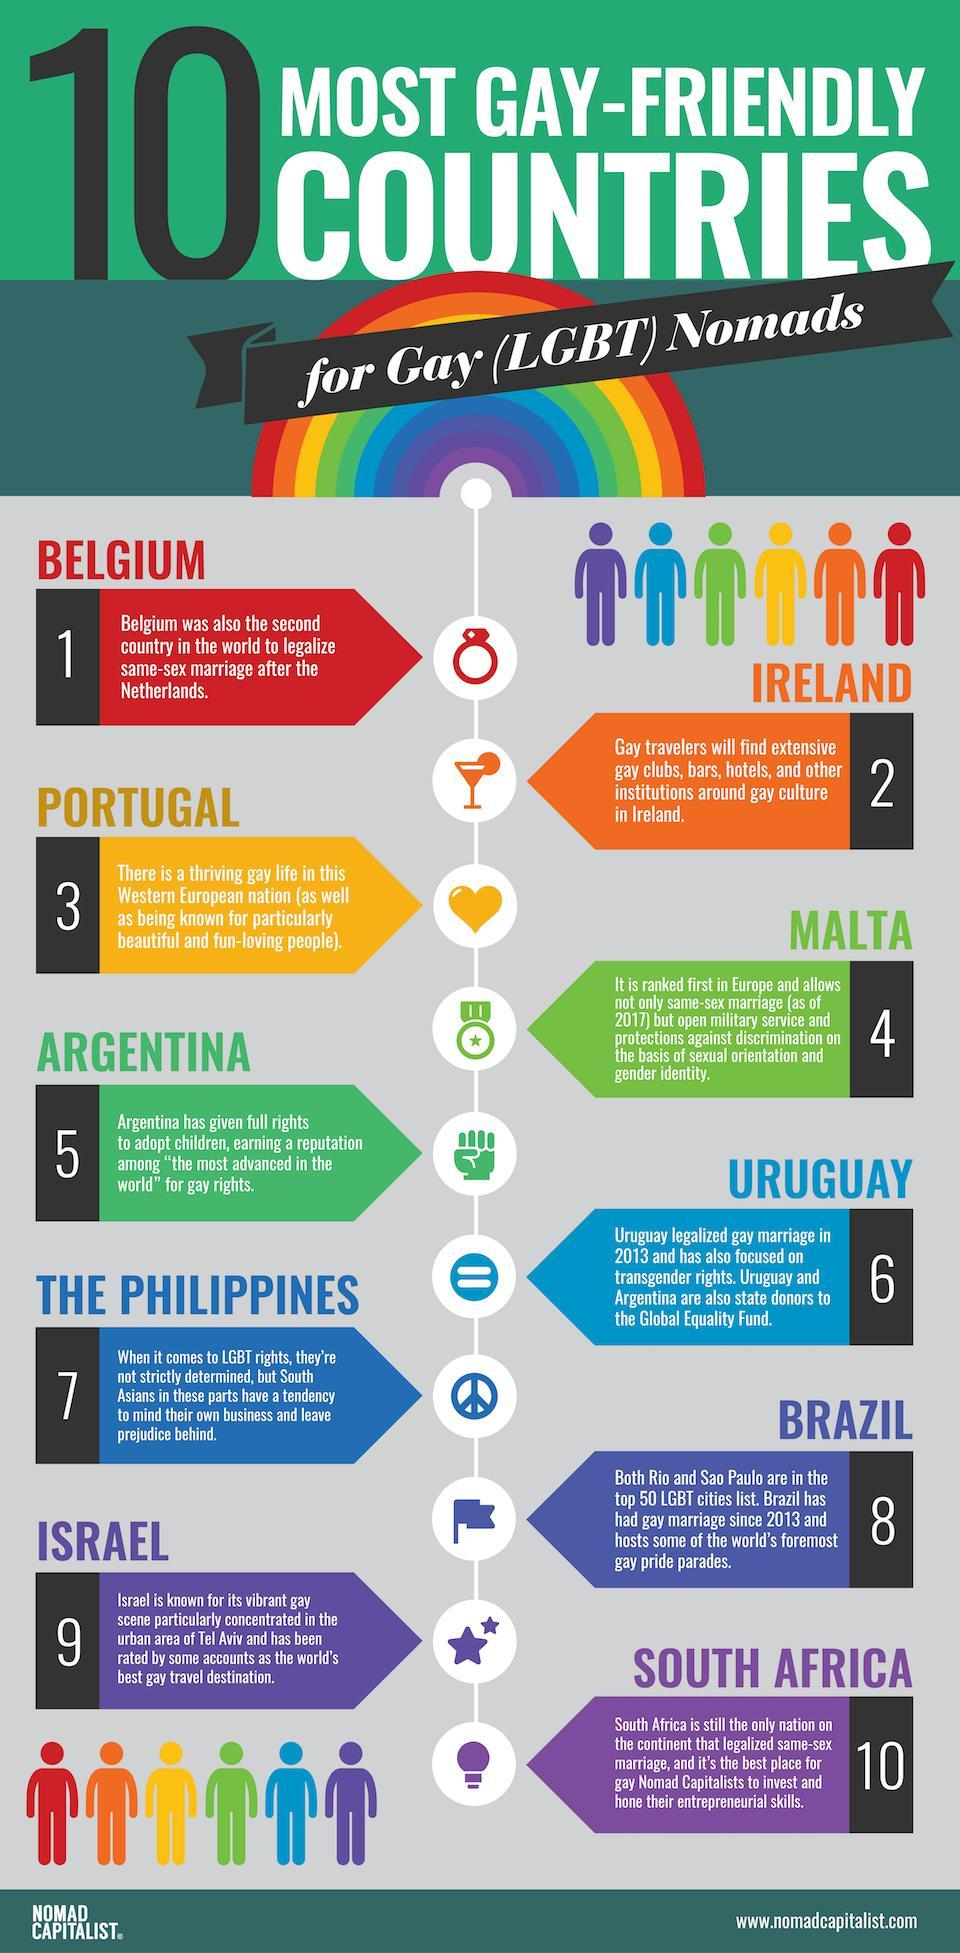Which country is rated as the world's best gay travel destination?
Answer the question with a short phrase. ISRAEL Which is the best place for gay Nomad Capitalists to invest & hone their entrepreneurial skills? SOUTH AFRICA Which country hosts the world's foremost gay pride parades? BRAZIL In which country, the gay travellers can find extensive gay clubs & bars? IRELAND Which is the second country in the world to legalize same-sex marriage after the Netherlands? BELGIUM Which Western European nation ensures a thriving gay life? PORTUGAL 